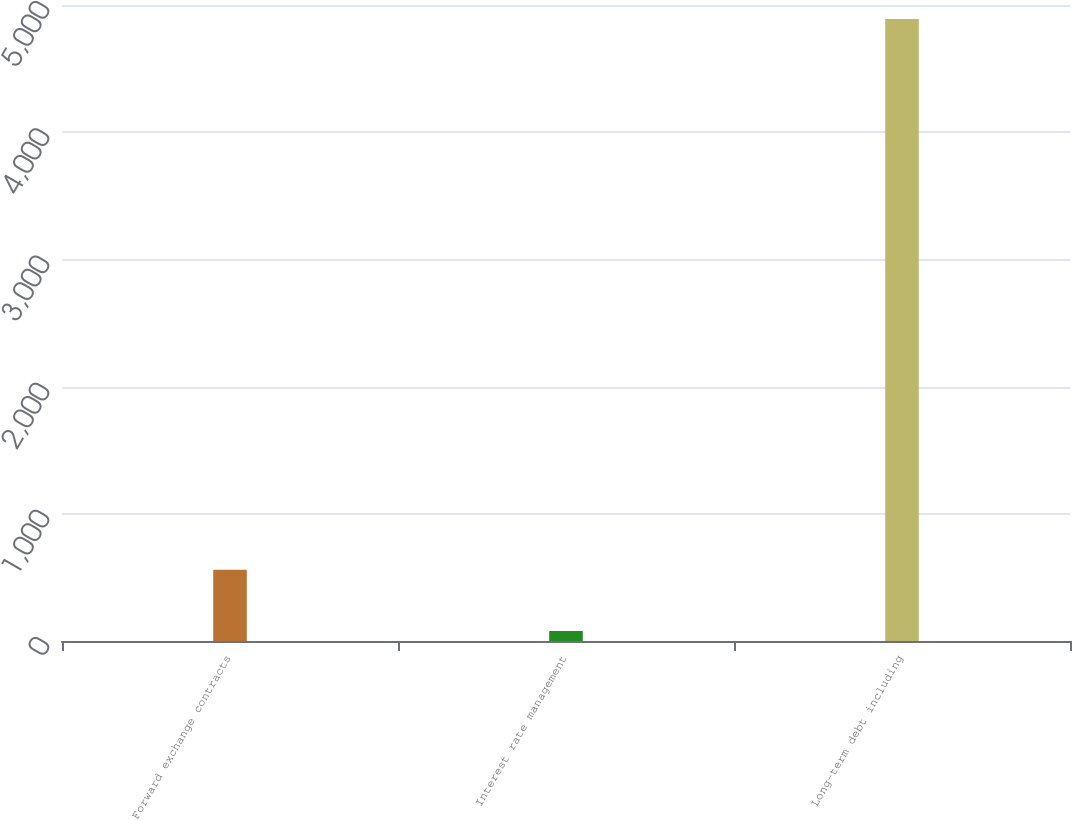Convert chart. <chart><loc_0><loc_0><loc_500><loc_500><bar_chart><fcel>Forward exchange contracts<fcel>Interest rate management<fcel>Long-term debt including<nl><fcel>559.45<fcel>78.3<fcel>4889.8<nl></chart> 